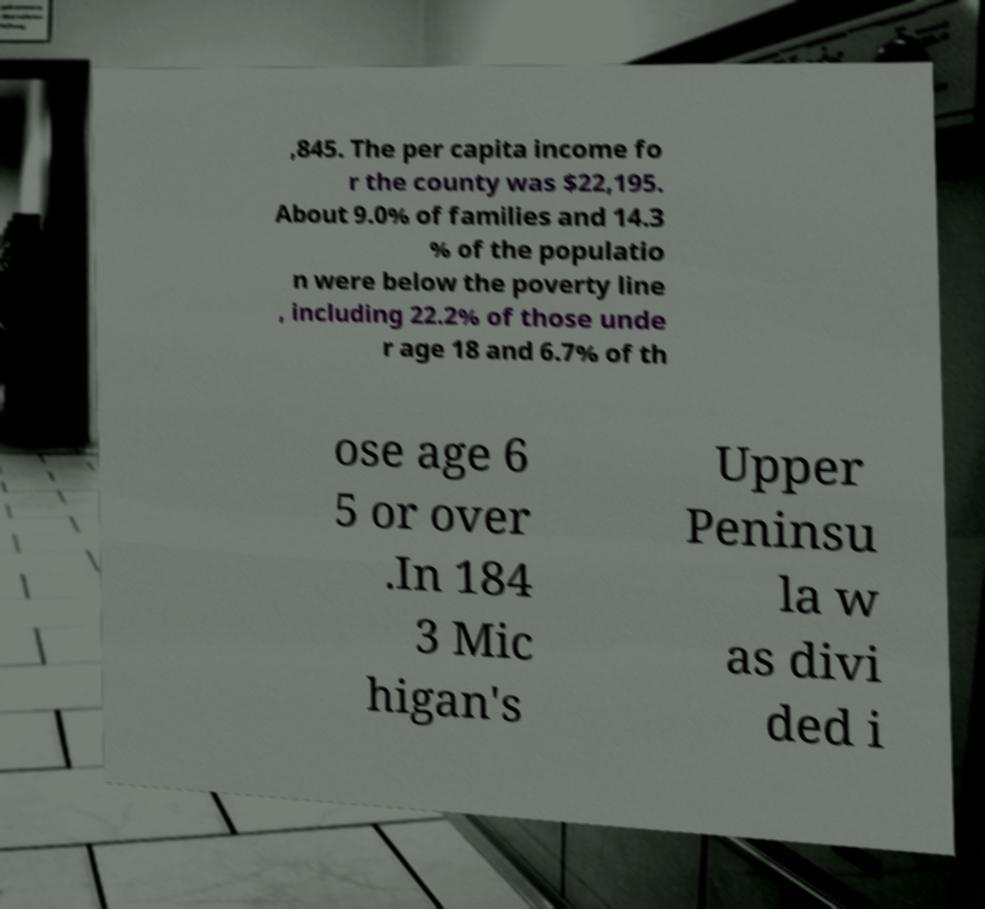Can you accurately transcribe the text from the provided image for me? ,845. The per capita income fo r the county was $22,195. About 9.0% of families and 14.3 % of the populatio n were below the poverty line , including 22.2% of those unde r age 18 and 6.7% of th ose age 6 5 or over .In 184 3 Mic higan's Upper Peninsu la w as divi ded i 